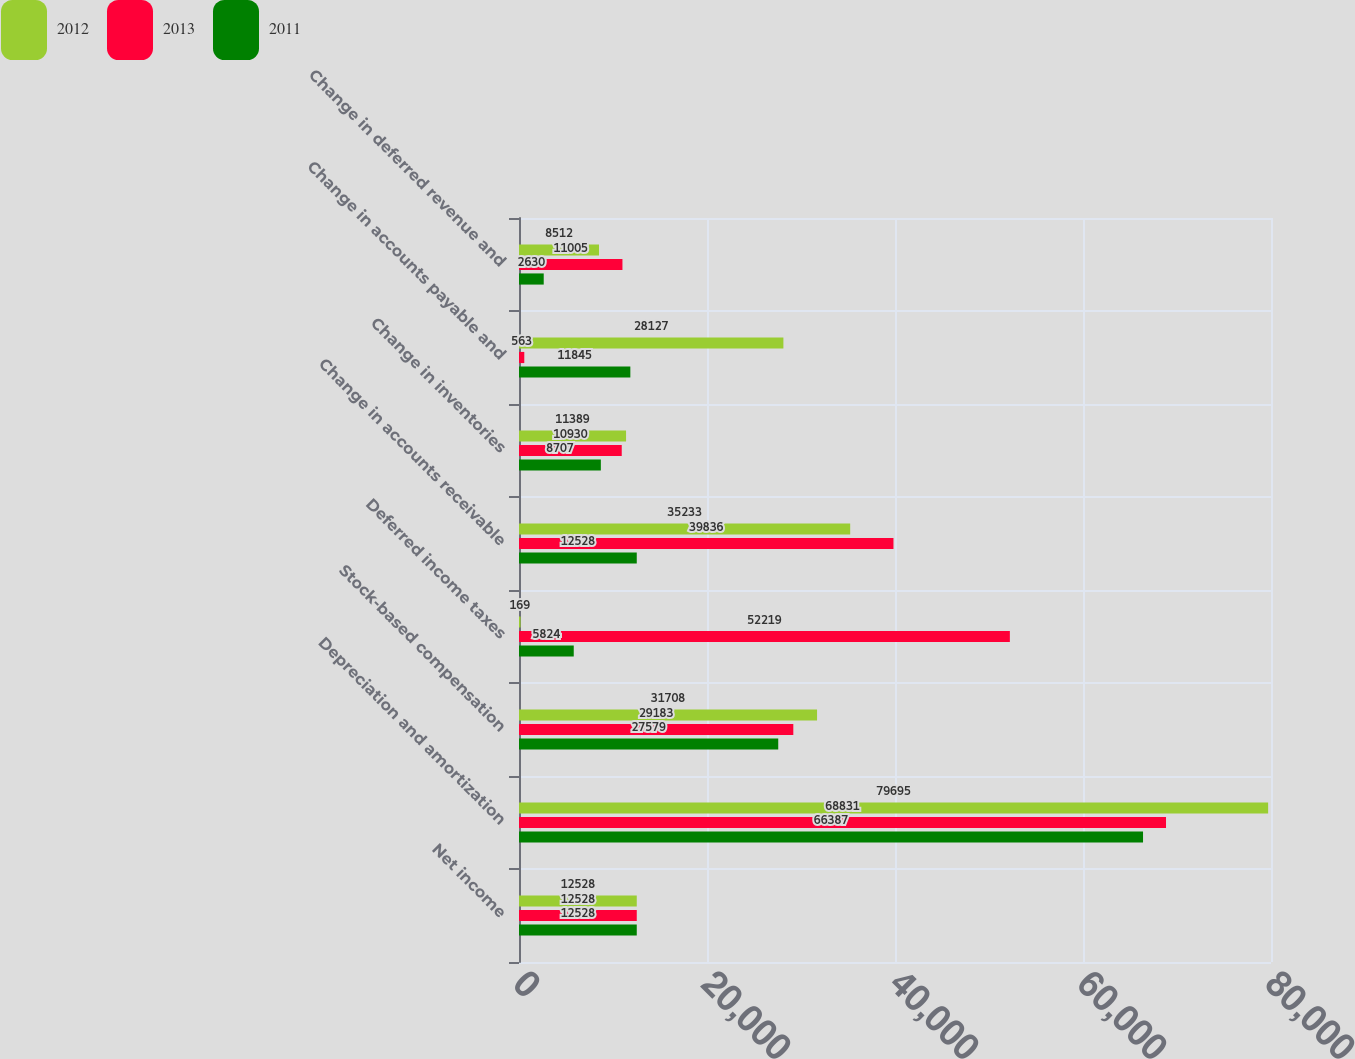Convert chart to OTSL. <chart><loc_0><loc_0><loc_500><loc_500><stacked_bar_chart><ecel><fcel>Net income<fcel>Depreciation and amortization<fcel>Stock-based compensation<fcel>Deferred income taxes<fcel>Change in accounts receivable<fcel>Change in inventories<fcel>Change in accounts payable and<fcel>Change in deferred revenue and<nl><fcel>2012<fcel>12528<fcel>79695<fcel>31708<fcel>169<fcel>35233<fcel>11389<fcel>28127<fcel>8512<nl><fcel>2013<fcel>12528<fcel>68831<fcel>29183<fcel>52219<fcel>39836<fcel>10930<fcel>563<fcel>11005<nl><fcel>2011<fcel>12528<fcel>66387<fcel>27579<fcel>5824<fcel>12528<fcel>8707<fcel>11845<fcel>2630<nl></chart> 